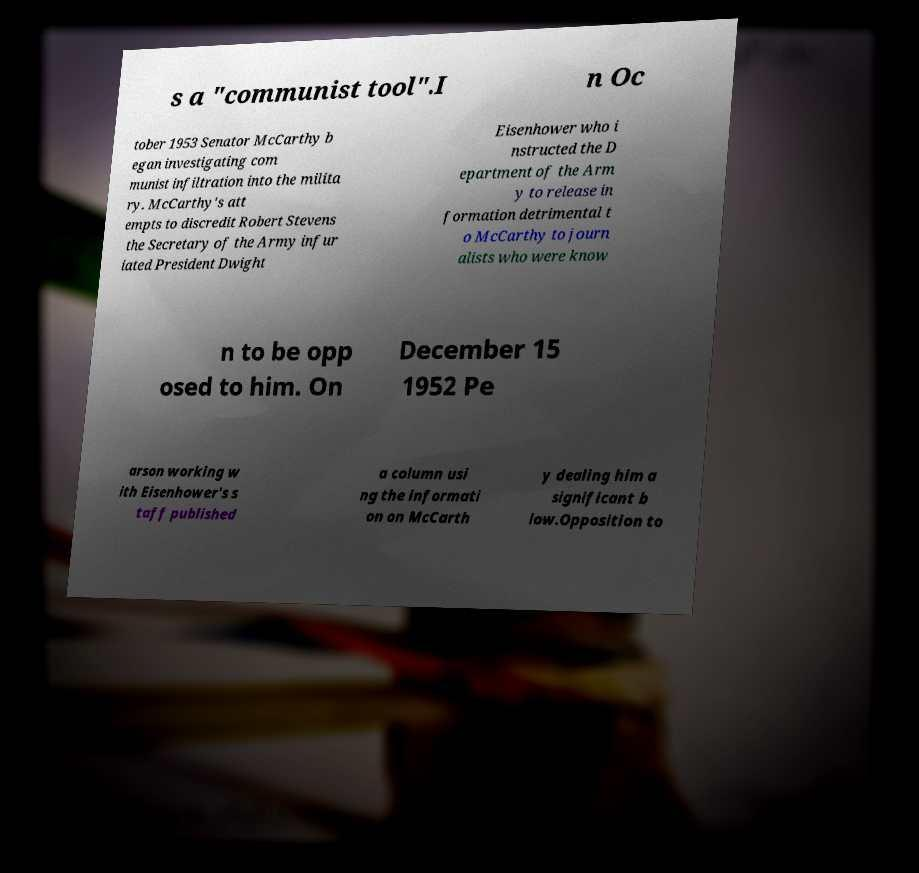Can you read and provide the text displayed in the image?This photo seems to have some interesting text. Can you extract and type it out for me? s a "communist tool".I n Oc tober 1953 Senator McCarthy b egan investigating com munist infiltration into the milita ry. McCarthy's att empts to discredit Robert Stevens the Secretary of the Army infur iated President Dwight Eisenhower who i nstructed the D epartment of the Arm y to release in formation detrimental t o McCarthy to journ alists who were know n to be opp osed to him. On December 15 1952 Pe arson working w ith Eisenhower's s taff published a column usi ng the informati on on McCarth y dealing him a significant b low.Opposition to 